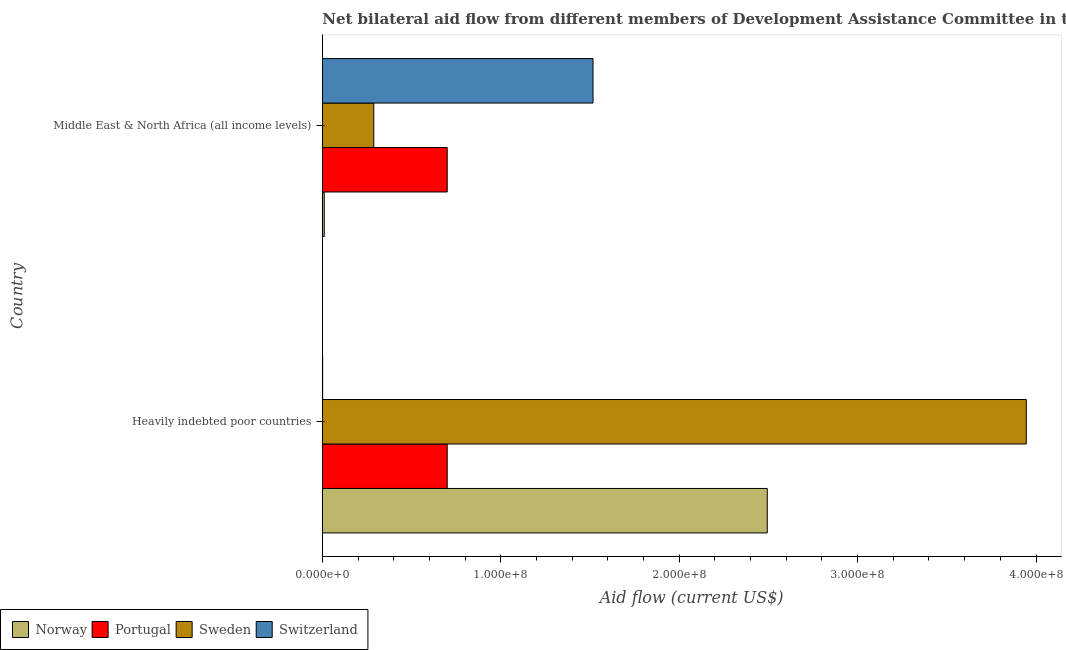Are the number of bars on each tick of the Y-axis equal?
Keep it short and to the point. Yes. How many bars are there on the 2nd tick from the bottom?
Provide a short and direct response. 4. What is the label of the 1st group of bars from the top?
Keep it short and to the point. Middle East & North Africa (all income levels). What is the amount of aid given by sweden in Middle East & North Africa (all income levels)?
Your answer should be very brief. 2.88e+07. Across all countries, what is the maximum amount of aid given by portugal?
Give a very brief answer. 7.00e+07. Across all countries, what is the minimum amount of aid given by norway?
Provide a short and direct response. 1.07e+06. In which country was the amount of aid given by norway maximum?
Your answer should be very brief. Heavily indebted poor countries. In which country was the amount of aid given by portugal minimum?
Offer a very short reply. Heavily indebted poor countries. What is the total amount of aid given by norway in the graph?
Provide a short and direct response. 2.50e+08. What is the difference between the amount of aid given by sweden in Heavily indebted poor countries and that in Middle East & North Africa (all income levels)?
Give a very brief answer. 3.66e+08. What is the difference between the amount of aid given by switzerland in Heavily indebted poor countries and the amount of aid given by sweden in Middle East & North Africa (all income levels)?
Your answer should be compact. -2.87e+07. What is the average amount of aid given by norway per country?
Ensure brevity in your answer.  1.25e+08. What is the difference between the amount of aid given by sweden and amount of aid given by norway in Middle East & North Africa (all income levels)?
Your response must be concise. 2.78e+07. In how many countries, is the amount of aid given by norway greater than 280000000 US$?
Offer a very short reply. 0. What is the ratio of the amount of aid given by norway in Heavily indebted poor countries to that in Middle East & North Africa (all income levels)?
Your response must be concise. 233.06. Is the amount of aid given by norway in Heavily indebted poor countries less than that in Middle East & North Africa (all income levels)?
Provide a short and direct response. No. Is the difference between the amount of aid given by sweden in Heavily indebted poor countries and Middle East & North Africa (all income levels) greater than the difference between the amount of aid given by portugal in Heavily indebted poor countries and Middle East & North Africa (all income levels)?
Your response must be concise. Yes. What does the 4th bar from the top in Heavily indebted poor countries represents?
Make the answer very short. Norway. Is it the case that in every country, the sum of the amount of aid given by norway and amount of aid given by portugal is greater than the amount of aid given by sweden?
Offer a very short reply. No. Are all the bars in the graph horizontal?
Your response must be concise. Yes. What is the difference between two consecutive major ticks on the X-axis?
Ensure brevity in your answer.  1.00e+08. Are the values on the major ticks of X-axis written in scientific E-notation?
Give a very brief answer. Yes. Does the graph contain any zero values?
Ensure brevity in your answer.  No. Does the graph contain grids?
Give a very brief answer. No. Where does the legend appear in the graph?
Your response must be concise. Bottom left. What is the title of the graph?
Make the answer very short. Net bilateral aid flow from different members of Development Assistance Committee in the year 1988. Does "SF6 gas" appear as one of the legend labels in the graph?
Ensure brevity in your answer.  No. What is the label or title of the Y-axis?
Offer a terse response. Country. What is the Aid flow (current US$) in Norway in Heavily indebted poor countries?
Give a very brief answer. 2.49e+08. What is the Aid flow (current US$) in Portugal in Heavily indebted poor countries?
Keep it short and to the point. 7.00e+07. What is the Aid flow (current US$) of Sweden in Heavily indebted poor countries?
Your answer should be very brief. 3.95e+08. What is the Aid flow (current US$) of Norway in Middle East & North Africa (all income levels)?
Keep it short and to the point. 1.07e+06. What is the Aid flow (current US$) in Portugal in Middle East & North Africa (all income levels)?
Give a very brief answer. 7.00e+07. What is the Aid flow (current US$) in Sweden in Middle East & North Africa (all income levels)?
Offer a very short reply. 2.88e+07. What is the Aid flow (current US$) of Switzerland in Middle East & North Africa (all income levels)?
Ensure brevity in your answer.  1.52e+08. Across all countries, what is the maximum Aid flow (current US$) of Norway?
Your answer should be compact. 2.49e+08. Across all countries, what is the maximum Aid flow (current US$) of Portugal?
Make the answer very short. 7.00e+07. Across all countries, what is the maximum Aid flow (current US$) in Sweden?
Your answer should be compact. 3.95e+08. Across all countries, what is the maximum Aid flow (current US$) in Switzerland?
Give a very brief answer. 1.52e+08. Across all countries, what is the minimum Aid flow (current US$) of Norway?
Keep it short and to the point. 1.07e+06. Across all countries, what is the minimum Aid flow (current US$) of Portugal?
Keep it short and to the point. 7.00e+07. Across all countries, what is the minimum Aid flow (current US$) of Sweden?
Make the answer very short. 2.88e+07. Across all countries, what is the minimum Aid flow (current US$) of Switzerland?
Give a very brief answer. 1.80e+05. What is the total Aid flow (current US$) of Norway in the graph?
Offer a very short reply. 2.50e+08. What is the total Aid flow (current US$) in Portugal in the graph?
Provide a short and direct response. 1.40e+08. What is the total Aid flow (current US$) of Sweden in the graph?
Your answer should be very brief. 4.23e+08. What is the total Aid flow (current US$) in Switzerland in the graph?
Your response must be concise. 1.52e+08. What is the difference between the Aid flow (current US$) in Norway in Heavily indebted poor countries and that in Middle East & North Africa (all income levels)?
Your answer should be very brief. 2.48e+08. What is the difference between the Aid flow (current US$) of Sweden in Heavily indebted poor countries and that in Middle East & North Africa (all income levels)?
Offer a very short reply. 3.66e+08. What is the difference between the Aid flow (current US$) in Switzerland in Heavily indebted poor countries and that in Middle East & North Africa (all income levels)?
Offer a terse response. -1.52e+08. What is the difference between the Aid flow (current US$) in Norway in Heavily indebted poor countries and the Aid flow (current US$) in Portugal in Middle East & North Africa (all income levels)?
Offer a very short reply. 1.79e+08. What is the difference between the Aid flow (current US$) in Norway in Heavily indebted poor countries and the Aid flow (current US$) in Sweden in Middle East & North Africa (all income levels)?
Make the answer very short. 2.21e+08. What is the difference between the Aid flow (current US$) in Norway in Heavily indebted poor countries and the Aid flow (current US$) in Switzerland in Middle East & North Africa (all income levels)?
Provide a succinct answer. 9.77e+07. What is the difference between the Aid flow (current US$) in Portugal in Heavily indebted poor countries and the Aid flow (current US$) in Sweden in Middle East & North Africa (all income levels)?
Your answer should be compact. 4.12e+07. What is the difference between the Aid flow (current US$) in Portugal in Heavily indebted poor countries and the Aid flow (current US$) in Switzerland in Middle East & North Africa (all income levels)?
Your answer should be compact. -8.17e+07. What is the difference between the Aid flow (current US$) of Sweden in Heavily indebted poor countries and the Aid flow (current US$) of Switzerland in Middle East & North Africa (all income levels)?
Offer a terse response. 2.43e+08. What is the average Aid flow (current US$) in Norway per country?
Your answer should be very brief. 1.25e+08. What is the average Aid flow (current US$) of Portugal per country?
Provide a succinct answer. 7.00e+07. What is the average Aid flow (current US$) of Sweden per country?
Provide a succinct answer. 2.12e+08. What is the average Aid flow (current US$) in Switzerland per country?
Keep it short and to the point. 7.60e+07. What is the difference between the Aid flow (current US$) of Norway and Aid flow (current US$) of Portugal in Heavily indebted poor countries?
Your answer should be compact. 1.79e+08. What is the difference between the Aid flow (current US$) in Norway and Aid flow (current US$) in Sweden in Heavily indebted poor countries?
Your response must be concise. -1.45e+08. What is the difference between the Aid flow (current US$) in Norway and Aid flow (current US$) in Switzerland in Heavily indebted poor countries?
Your response must be concise. 2.49e+08. What is the difference between the Aid flow (current US$) in Portugal and Aid flow (current US$) in Sweden in Heavily indebted poor countries?
Give a very brief answer. -3.25e+08. What is the difference between the Aid flow (current US$) of Portugal and Aid flow (current US$) of Switzerland in Heavily indebted poor countries?
Provide a short and direct response. 6.98e+07. What is the difference between the Aid flow (current US$) of Sweden and Aid flow (current US$) of Switzerland in Heavily indebted poor countries?
Make the answer very short. 3.94e+08. What is the difference between the Aid flow (current US$) of Norway and Aid flow (current US$) of Portugal in Middle East & North Africa (all income levels)?
Your answer should be very brief. -6.89e+07. What is the difference between the Aid flow (current US$) of Norway and Aid flow (current US$) of Sweden in Middle East & North Africa (all income levels)?
Provide a short and direct response. -2.78e+07. What is the difference between the Aid flow (current US$) in Norway and Aid flow (current US$) in Switzerland in Middle East & North Africa (all income levels)?
Offer a terse response. -1.51e+08. What is the difference between the Aid flow (current US$) in Portugal and Aid flow (current US$) in Sweden in Middle East & North Africa (all income levels)?
Give a very brief answer. 4.12e+07. What is the difference between the Aid flow (current US$) in Portugal and Aid flow (current US$) in Switzerland in Middle East & North Africa (all income levels)?
Provide a short and direct response. -8.17e+07. What is the difference between the Aid flow (current US$) of Sweden and Aid flow (current US$) of Switzerland in Middle East & North Africa (all income levels)?
Make the answer very short. -1.23e+08. What is the ratio of the Aid flow (current US$) in Norway in Heavily indebted poor countries to that in Middle East & North Africa (all income levels)?
Give a very brief answer. 233.07. What is the ratio of the Aid flow (current US$) in Portugal in Heavily indebted poor countries to that in Middle East & North Africa (all income levels)?
Provide a succinct answer. 1. What is the ratio of the Aid flow (current US$) of Sweden in Heavily indebted poor countries to that in Middle East & North Africa (all income levels)?
Your response must be concise. 13.68. What is the ratio of the Aid flow (current US$) in Switzerland in Heavily indebted poor countries to that in Middle East & North Africa (all income levels)?
Offer a terse response. 0. What is the difference between the highest and the second highest Aid flow (current US$) of Norway?
Offer a terse response. 2.48e+08. What is the difference between the highest and the second highest Aid flow (current US$) in Sweden?
Make the answer very short. 3.66e+08. What is the difference between the highest and the second highest Aid flow (current US$) of Switzerland?
Ensure brevity in your answer.  1.52e+08. What is the difference between the highest and the lowest Aid flow (current US$) in Norway?
Your answer should be compact. 2.48e+08. What is the difference between the highest and the lowest Aid flow (current US$) of Sweden?
Your answer should be very brief. 3.66e+08. What is the difference between the highest and the lowest Aid flow (current US$) of Switzerland?
Your response must be concise. 1.52e+08. 